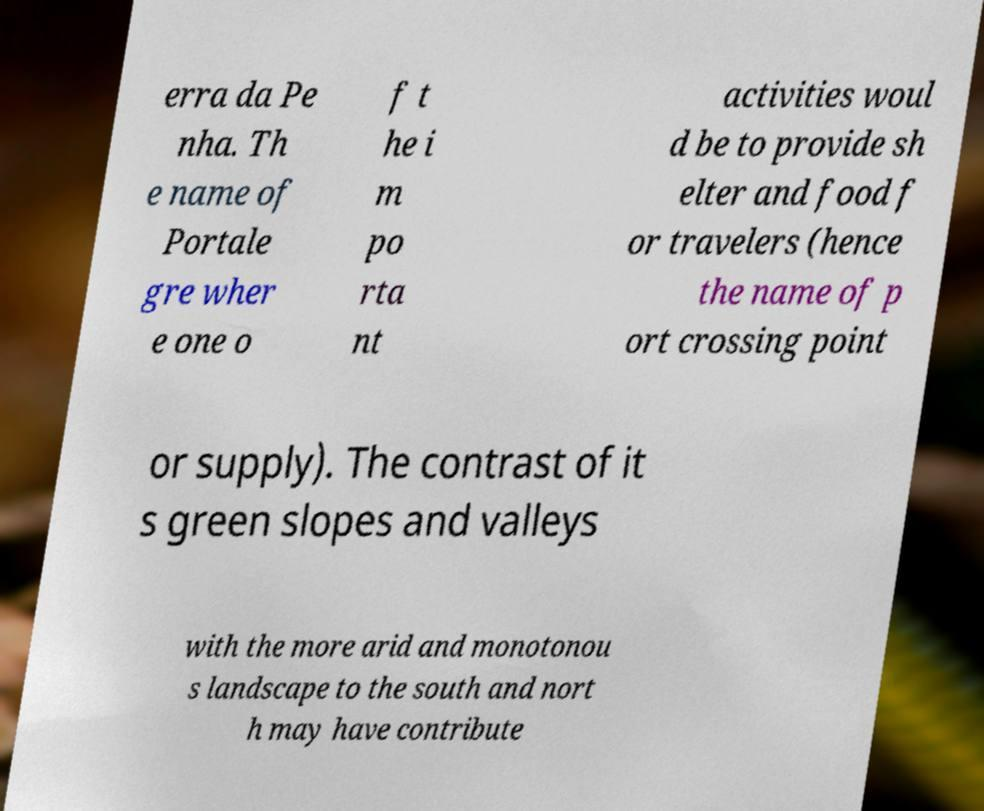I need the written content from this picture converted into text. Can you do that? erra da Pe nha. Th e name of Portale gre wher e one o f t he i m po rta nt activities woul d be to provide sh elter and food f or travelers (hence the name of p ort crossing point or supply). The contrast of it s green slopes and valleys with the more arid and monotonou s landscape to the south and nort h may have contribute 